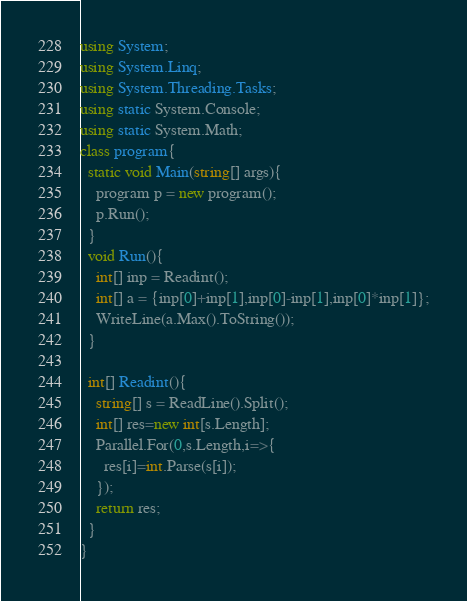Convert code to text. <code><loc_0><loc_0><loc_500><loc_500><_C#_>using System;
using System.Linq;
using System.Threading.Tasks;
using static System.Console;
using static System.Math;
class program{
  static void Main(string[] args){
    program p = new program();
    p.Run();
  }
  void Run(){
	int[] inp = Readint();
    int[] a = {inp[0]+inp[1],inp[0]-inp[1],inp[0]*inp[1]};
   	WriteLine(a.Max().ToString());
  }

  int[] Readint(){
    string[] s = ReadLine().Split();
    int[] res=new int[s.Length];
    Parallel.For(0,s.Length,i=>{
      res[i]=int.Parse(s[i]);
    });
    return res;
  }
}</code> 